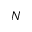Convert formula to latex. <formula><loc_0><loc_0><loc_500><loc_500>N</formula> 